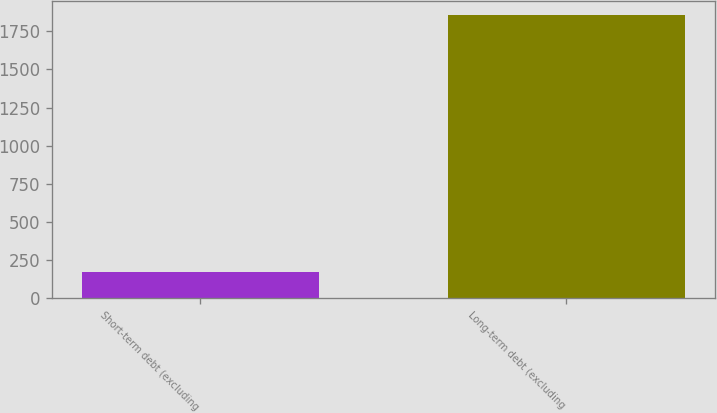Convert chart. <chart><loc_0><loc_0><loc_500><loc_500><bar_chart><fcel>Short-term debt (excluding<fcel>Long-term debt (excluding<nl><fcel>173<fcel>1858<nl></chart> 